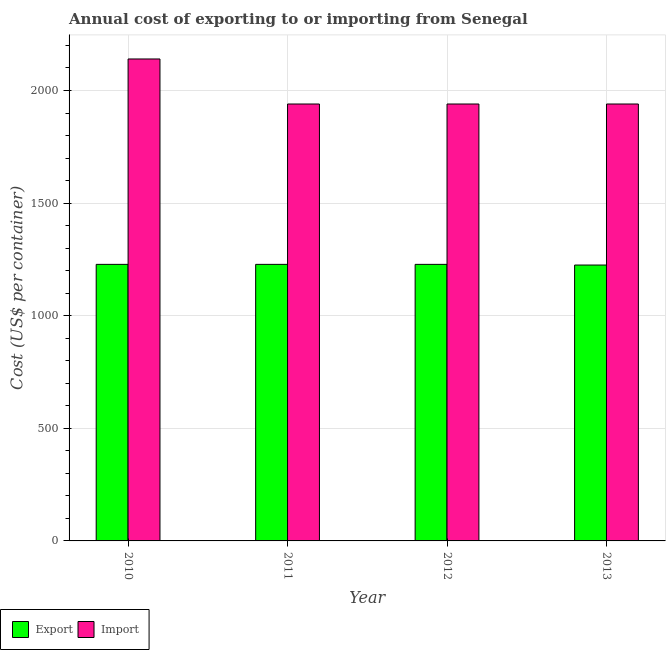How many different coloured bars are there?
Keep it short and to the point. 2. How many groups of bars are there?
Provide a short and direct response. 4. Are the number of bars on each tick of the X-axis equal?
Make the answer very short. Yes. How many bars are there on the 4th tick from the left?
Provide a succinct answer. 2. What is the label of the 2nd group of bars from the left?
Offer a terse response. 2011. What is the import cost in 2010?
Give a very brief answer. 2140. Across all years, what is the maximum export cost?
Make the answer very short. 1228. Across all years, what is the minimum import cost?
Your response must be concise. 1940. In which year was the export cost minimum?
Make the answer very short. 2013. What is the total import cost in the graph?
Provide a short and direct response. 7960. What is the difference between the import cost in 2010 and that in 2011?
Keep it short and to the point. 200. What is the difference between the export cost in 2011 and the import cost in 2010?
Make the answer very short. 0. What is the average import cost per year?
Ensure brevity in your answer.  1990. What is the ratio of the import cost in 2010 to that in 2012?
Your answer should be compact. 1.1. Is the import cost in 2010 less than that in 2012?
Give a very brief answer. No. What is the difference between the highest and the second highest import cost?
Offer a very short reply. 200. What is the difference between the highest and the lowest import cost?
Your response must be concise. 200. In how many years, is the import cost greater than the average import cost taken over all years?
Your answer should be compact. 1. Is the sum of the export cost in 2010 and 2012 greater than the maximum import cost across all years?
Provide a short and direct response. Yes. What does the 2nd bar from the left in 2012 represents?
Provide a short and direct response. Import. What does the 1st bar from the right in 2010 represents?
Your answer should be very brief. Import. What is the difference between two consecutive major ticks on the Y-axis?
Offer a terse response. 500. Where does the legend appear in the graph?
Your answer should be compact. Bottom left. How many legend labels are there?
Give a very brief answer. 2. How are the legend labels stacked?
Your answer should be compact. Horizontal. What is the title of the graph?
Your answer should be compact. Annual cost of exporting to or importing from Senegal. Does "Death rate" appear as one of the legend labels in the graph?
Keep it short and to the point. No. What is the label or title of the X-axis?
Provide a short and direct response. Year. What is the label or title of the Y-axis?
Ensure brevity in your answer.  Cost (US$ per container). What is the Cost (US$ per container) of Export in 2010?
Ensure brevity in your answer.  1228. What is the Cost (US$ per container) in Import in 2010?
Your answer should be very brief. 2140. What is the Cost (US$ per container) in Export in 2011?
Provide a short and direct response. 1228. What is the Cost (US$ per container) in Import in 2011?
Make the answer very short. 1940. What is the Cost (US$ per container) in Export in 2012?
Provide a succinct answer. 1228. What is the Cost (US$ per container) in Import in 2012?
Offer a very short reply. 1940. What is the Cost (US$ per container) in Export in 2013?
Ensure brevity in your answer.  1225. What is the Cost (US$ per container) in Import in 2013?
Provide a succinct answer. 1940. Across all years, what is the maximum Cost (US$ per container) in Export?
Offer a terse response. 1228. Across all years, what is the maximum Cost (US$ per container) in Import?
Give a very brief answer. 2140. Across all years, what is the minimum Cost (US$ per container) in Export?
Provide a short and direct response. 1225. Across all years, what is the minimum Cost (US$ per container) of Import?
Offer a terse response. 1940. What is the total Cost (US$ per container) of Export in the graph?
Your answer should be compact. 4909. What is the total Cost (US$ per container) of Import in the graph?
Provide a short and direct response. 7960. What is the difference between the Cost (US$ per container) in Import in 2012 and that in 2013?
Ensure brevity in your answer.  0. What is the difference between the Cost (US$ per container) in Export in 2010 and the Cost (US$ per container) in Import in 2011?
Provide a succinct answer. -712. What is the difference between the Cost (US$ per container) of Export in 2010 and the Cost (US$ per container) of Import in 2012?
Provide a short and direct response. -712. What is the difference between the Cost (US$ per container) in Export in 2010 and the Cost (US$ per container) in Import in 2013?
Ensure brevity in your answer.  -712. What is the difference between the Cost (US$ per container) of Export in 2011 and the Cost (US$ per container) of Import in 2012?
Your answer should be very brief. -712. What is the difference between the Cost (US$ per container) of Export in 2011 and the Cost (US$ per container) of Import in 2013?
Keep it short and to the point. -712. What is the difference between the Cost (US$ per container) in Export in 2012 and the Cost (US$ per container) in Import in 2013?
Your answer should be compact. -712. What is the average Cost (US$ per container) in Export per year?
Give a very brief answer. 1227.25. What is the average Cost (US$ per container) of Import per year?
Your answer should be very brief. 1990. In the year 2010, what is the difference between the Cost (US$ per container) of Export and Cost (US$ per container) of Import?
Keep it short and to the point. -912. In the year 2011, what is the difference between the Cost (US$ per container) in Export and Cost (US$ per container) in Import?
Provide a succinct answer. -712. In the year 2012, what is the difference between the Cost (US$ per container) in Export and Cost (US$ per container) in Import?
Your response must be concise. -712. In the year 2013, what is the difference between the Cost (US$ per container) in Export and Cost (US$ per container) in Import?
Offer a very short reply. -715. What is the ratio of the Cost (US$ per container) of Export in 2010 to that in 2011?
Keep it short and to the point. 1. What is the ratio of the Cost (US$ per container) in Import in 2010 to that in 2011?
Your answer should be compact. 1.1. What is the ratio of the Cost (US$ per container) of Import in 2010 to that in 2012?
Your response must be concise. 1.1. What is the ratio of the Cost (US$ per container) in Export in 2010 to that in 2013?
Provide a short and direct response. 1. What is the ratio of the Cost (US$ per container) in Import in 2010 to that in 2013?
Keep it short and to the point. 1.1. What is the ratio of the Cost (US$ per container) in Import in 2011 to that in 2012?
Ensure brevity in your answer.  1. What is the ratio of the Cost (US$ per container) of Export in 2011 to that in 2013?
Make the answer very short. 1. What is the ratio of the Cost (US$ per container) in Import in 2011 to that in 2013?
Provide a short and direct response. 1. What is the ratio of the Cost (US$ per container) in Export in 2012 to that in 2013?
Make the answer very short. 1. What is the ratio of the Cost (US$ per container) of Import in 2012 to that in 2013?
Ensure brevity in your answer.  1. What is the difference between the highest and the second highest Cost (US$ per container) of Export?
Give a very brief answer. 0. What is the difference between the highest and the lowest Cost (US$ per container) of Export?
Provide a short and direct response. 3. What is the difference between the highest and the lowest Cost (US$ per container) in Import?
Provide a short and direct response. 200. 